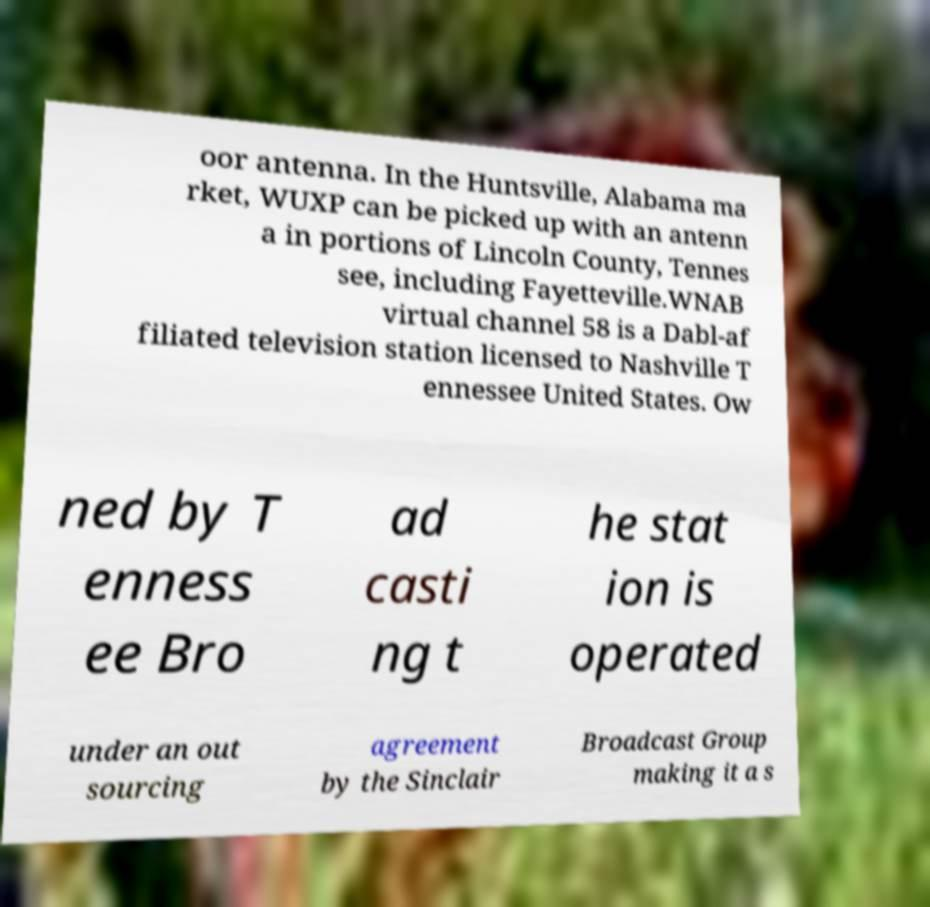Please identify and transcribe the text found in this image. oor antenna. In the Huntsville, Alabama ma rket, WUXP can be picked up with an antenn a in portions of Lincoln County, Tennes see, including Fayetteville.WNAB virtual channel 58 is a Dabl-af filiated television station licensed to Nashville T ennessee United States. Ow ned by T enness ee Bro ad casti ng t he stat ion is operated under an out sourcing agreement by the Sinclair Broadcast Group making it a s 